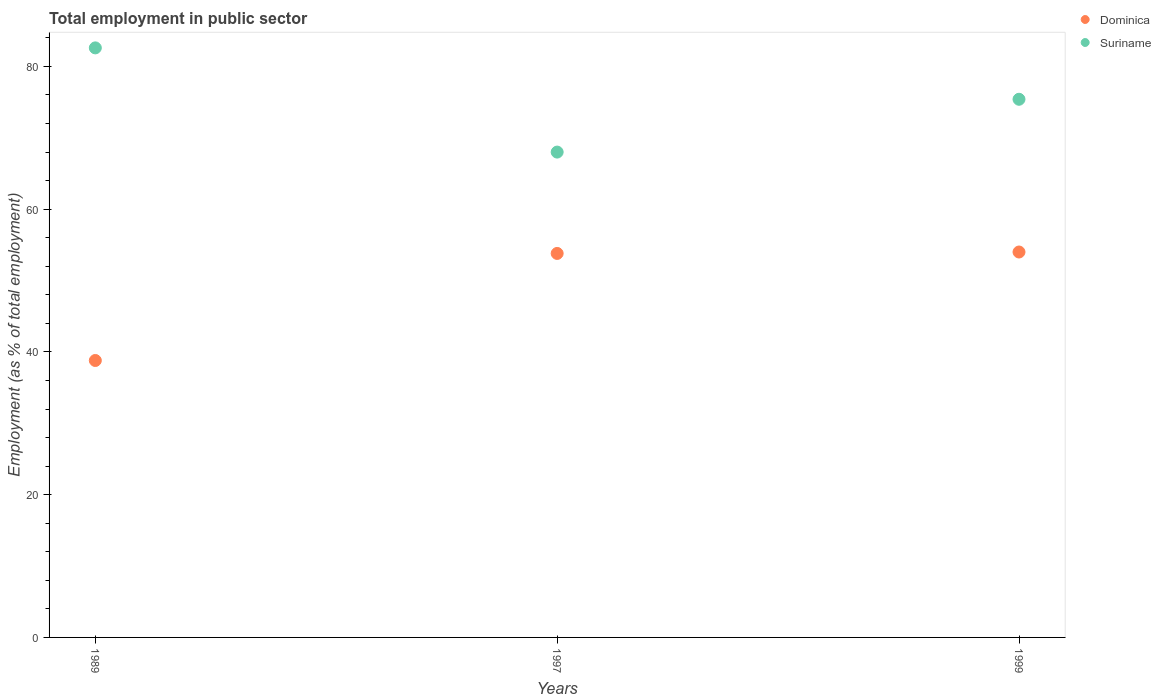How many different coloured dotlines are there?
Provide a succinct answer. 2. Is the number of dotlines equal to the number of legend labels?
Offer a very short reply. Yes. Across all years, what is the maximum employment in public sector in Suriname?
Your answer should be compact. 82.6. Across all years, what is the minimum employment in public sector in Suriname?
Your answer should be compact. 68. In which year was the employment in public sector in Suriname maximum?
Your answer should be very brief. 1989. In which year was the employment in public sector in Dominica minimum?
Offer a very short reply. 1989. What is the total employment in public sector in Dominica in the graph?
Make the answer very short. 146.6. What is the difference between the employment in public sector in Dominica in 1989 and that in 1997?
Offer a terse response. -15. What is the difference between the employment in public sector in Dominica in 1989 and the employment in public sector in Suriname in 1997?
Provide a succinct answer. -29.2. What is the average employment in public sector in Suriname per year?
Ensure brevity in your answer.  75.33. In the year 1997, what is the difference between the employment in public sector in Dominica and employment in public sector in Suriname?
Provide a short and direct response. -14.2. What is the ratio of the employment in public sector in Suriname in 1989 to that in 1997?
Provide a short and direct response. 1.21. Is the difference between the employment in public sector in Dominica in 1989 and 1997 greater than the difference between the employment in public sector in Suriname in 1989 and 1997?
Give a very brief answer. No. What is the difference between the highest and the second highest employment in public sector in Dominica?
Give a very brief answer. 0.2. What is the difference between the highest and the lowest employment in public sector in Dominica?
Your answer should be very brief. 15.2. In how many years, is the employment in public sector in Suriname greater than the average employment in public sector in Suriname taken over all years?
Keep it short and to the point. 2. Is the employment in public sector in Dominica strictly greater than the employment in public sector in Suriname over the years?
Offer a terse response. No. Is the employment in public sector in Suriname strictly less than the employment in public sector in Dominica over the years?
Offer a very short reply. No. How many dotlines are there?
Offer a very short reply. 2. How many years are there in the graph?
Give a very brief answer. 3. What is the difference between two consecutive major ticks on the Y-axis?
Give a very brief answer. 20. Does the graph contain any zero values?
Your answer should be very brief. No. How many legend labels are there?
Your answer should be compact. 2. What is the title of the graph?
Give a very brief answer. Total employment in public sector. What is the label or title of the Y-axis?
Give a very brief answer. Employment (as % of total employment). What is the Employment (as % of total employment) in Dominica in 1989?
Offer a terse response. 38.8. What is the Employment (as % of total employment) of Suriname in 1989?
Give a very brief answer. 82.6. What is the Employment (as % of total employment) of Dominica in 1997?
Your answer should be compact. 53.8. What is the Employment (as % of total employment) of Suriname in 1999?
Your answer should be very brief. 75.4. Across all years, what is the maximum Employment (as % of total employment) of Suriname?
Ensure brevity in your answer.  82.6. Across all years, what is the minimum Employment (as % of total employment) in Dominica?
Give a very brief answer. 38.8. What is the total Employment (as % of total employment) in Dominica in the graph?
Make the answer very short. 146.6. What is the total Employment (as % of total employment) in Suriname in the graph?
Ensure brevity in your answer.  226. What is the difference between the Employment (as % of total employment) of Suriname in 1989 and that in 1997?
Keep it short and to the point. 14.6. What is the difference between the Employment (as % of total employment) of Dominica in 1989 and that in 1999?
Ensure brevity in your answer.  -15.2. What is the difference between the Employment (as % of total employment) of Suriname in 1989 and that in 1999?
Provide a succinct answer. 7.2. What is the difference between the Employment (as % of total employment) in Dominica in 1997 and that in 1999?
Give a very brief answer. -0.2. What is the difference between the Employment (as % of total employment) of Suriname in 1997 and that in 1999?
Your answer should be very brief. -7.4. What is the difference between the Employment (as % of total employment) in Dominica in 1989 and the Employment (as % of total employment) in Suriname in 1997?
Provide a short and direct response. -29.2. What is the difference between the Employment (as % of total employment) of Dominica in 1989 and the Employment (as % of total employment) of Suriname in 1999?
Make the answer very short. -36.6. What is the difference between the Employment (as % of total employment) in Dominica in 1997 and the Employment (as % of total employment) in Suriname in 1999?
Offer a very short reply. -21.6. What is the average Employment (as % of total employment) in Dominica per year?
Your answer should be compact. 48.87. What is the average Employment (as % of total employment) of Suriname per year?
Provide a short and direct response. 75.33. In the year 1989, what is the difference between the Employment (as % of total employment) in Dominica and Employment (as % of total employment) in Suriname?
Your answer should be compact. -43.8. In the year 1997, what is the difference between the Employment (as % of total employment) of Dominica and Employment (as % of total employment) of Suriname?
Provide a succinct answer. -14.2. In the year 1999, what is the difference between the Employment (as % of total employment) of Dominica and Employment (as % of total employment) of Suriname?
Your answer should be compact. -21.4. What is the ratio of the Employment (as % of total employment) of Dominica in 1989 to that in 1997?
Make the answer very short. 0.72. What is the ratio of the Employment (as % of total employment) of Suriname in 1989 to that in 1997?
Provide a succinct answer. 1.21. What is the ratio of the Employment (as % of total employment) in Dominica in 1989 to that in 1999?
Offer a terse response. 0.72. What is the ratio of the Employment (as % of total employment) of Suriname in 1989 to that in 1999?
Offer a terse response. 1.1. What is the ratio of the Employment (as % of total employment) of Dominica in 1997 to that in 1999?
Your response must be concise. 1. What is the ratio of the Employment (as % of total employment) in Suriname in 1997 to that in 1999?
Your response must be concise. 0.9. What is the difference between the highest and the lowest Employment (as % of total employment) of Dominica?
Provide a succinct answer. 15.2. What is the difference between the highest and the lowest Employment (as % of total employment) of Suriname?
Your answer should be very brief. 14.6. 